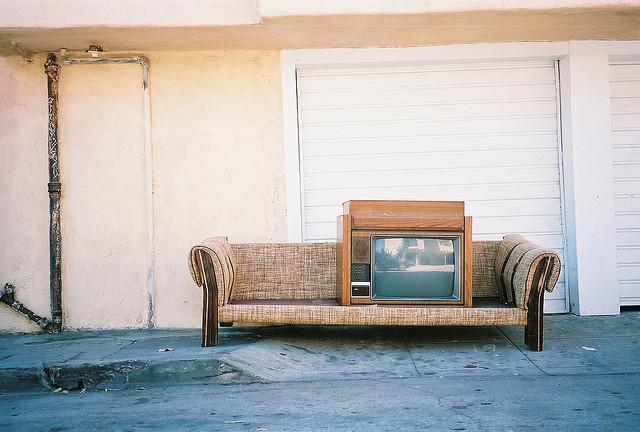How many people are holding skateboards?
Give a very brief answer. 0. 